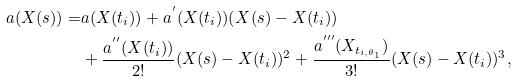Convert formula to latex. <formula><loc_0><loc_0><loc_500><loc_500>a ( X ( s ) ) = & a ( X ( t _ { i } ) ) + a ^ { ^ { \prime } } ( X ( t _ { i } ) ) ( X ( s ) - X ( t _ { i } ) ) \\ & + \frac { a ^ { ^ { \prime \prime } } ( X ( t _ { i } ) ) } { 2 ! } ( X ( s ) - X ( t _ { i } ) ) ^ { 2 } + \frac { a ^ { ^ { \prime \prime \prime } } ( X _ { t _ { i , \theta _ { 1 } } } ) } { 3 ! } ( X ( s ) - X ( t _ { i } ) ) ^ { 3 } ,</formula> 